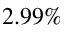<formula> <loc_0><loc_0><loc_500><loc_500>2 . 9 9 \%</formula> 